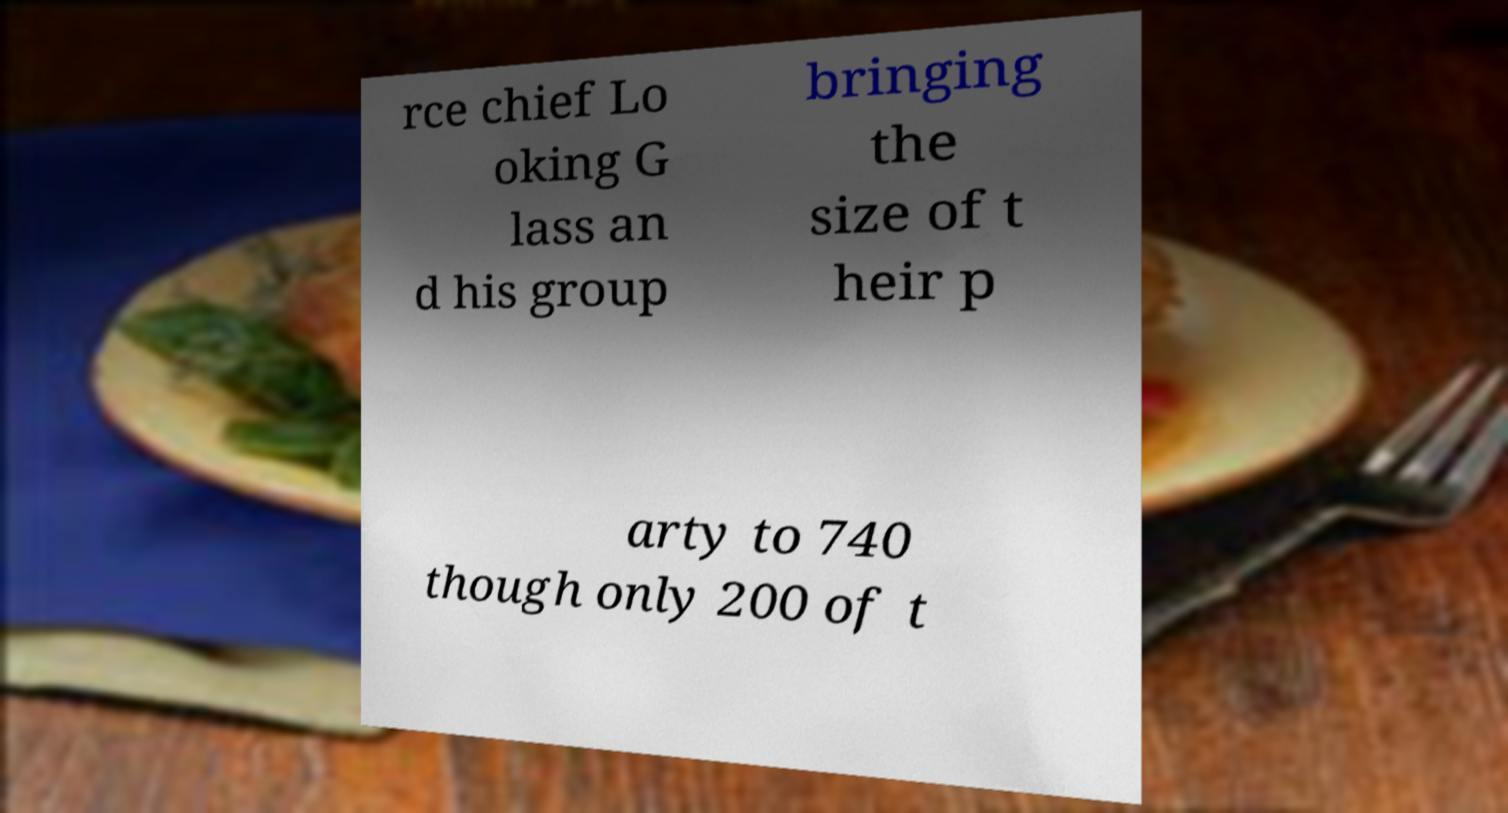Could you assist in decoding the text presented in this image and type it out clearly? rce chief Lo oking G lass an d his group bringing the size of t heir p arty to 740 though only 200 of t 